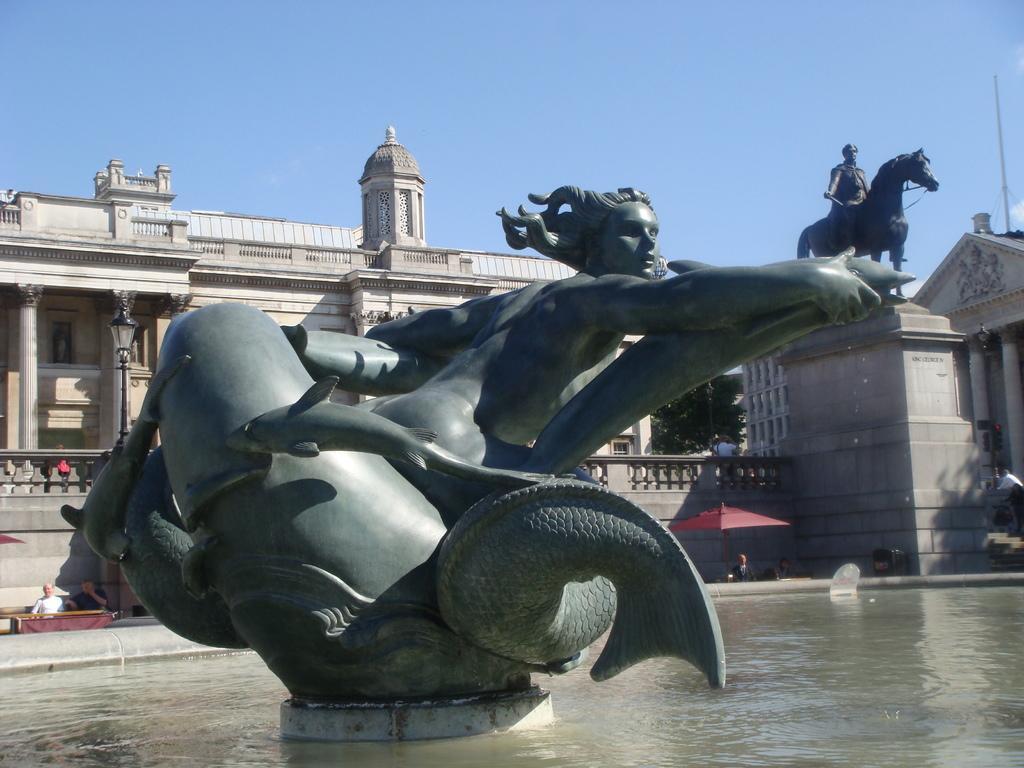Could you give a brief overview of what you see in this image? In the picture we can see the sculpture in the water and behind it, we can see the building and beside it also we can see another building with pillars and in the background we can see the sky. 